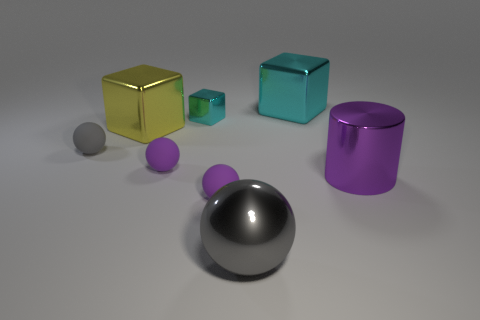What number of objects are either tiny brown balls or tiny objects on the right side of the yellow metal thing?
Make the answer very short. 3. There is a object that is in front of the large purple metallic cylinder and behind the gray shiny thing; what shape is it?
Provide a succinct answer. Sphere. What material is the gray ball that is on the right side of the gray sphere left of the yellow metallic object?
Your response must be concise. Metal. Does the gray thing in front of the purple metallic cylinder have the same material as the cylinder?
Give a very brief answer. Yes. How big is the purple matte object that is behind the purple metal thing?
Ensure brevity in your answer.  Small. Is there a thing that is in front of the large shiny object in front of the purple metallic thing?
Make the answer very short. No. There is a matte ball on the left side of the big yellow block; is its color the same as the big block that is on the right side of the yellow metallic block?
Keep it short and to the point. No. What color is the tiny block?
Keep it short and to the point. Cyan. Are there any other things that have the same color as the cylinder?
Your response must be concise. Yes. There is a big object that is behind the cylinder and to the right of the gray shiny sphere; what color is it?
Make the answer very short. Cyan. 